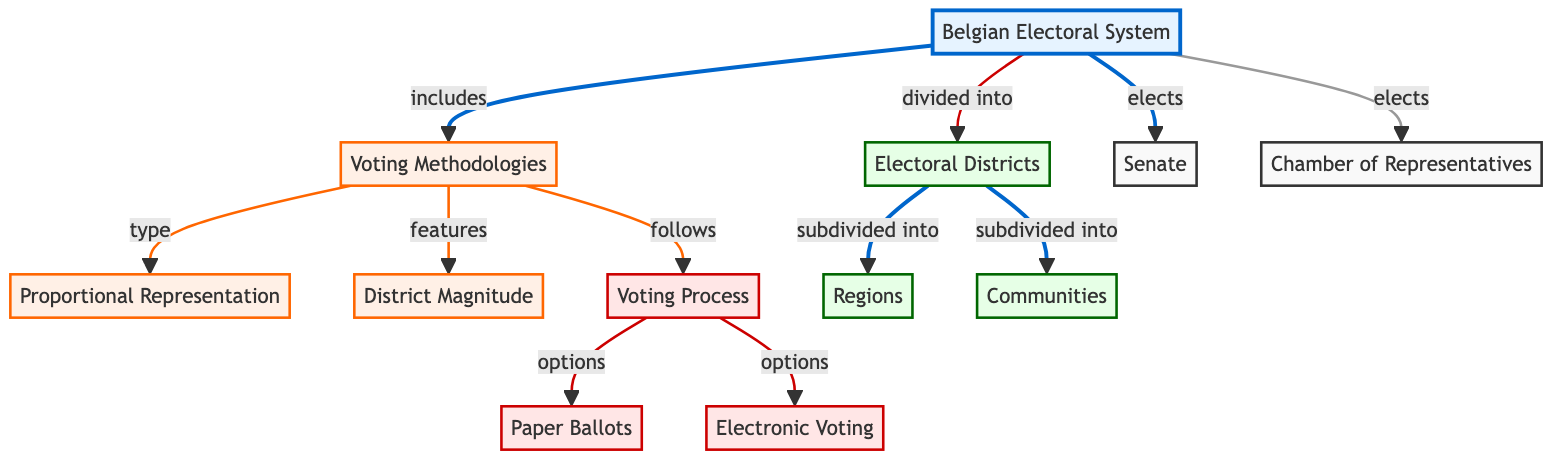What is the main focus of the diagram? The diagram's main focus is the "Belgian Electoral System," which is represented as the central node labeled 1.
Answer: Belgian Electoral System How many voting methodologies are listed in the diagram? In the diagram, there are three voting methodologies identified: Proportional Representation, District Magnitude, and Voting Process. This is counted under node 2.
Answer: three What two types of voting processes are mentioned? The diagram shows two types of voting processes: Paper Ballots and Electronic Voting, both of which are linked to the Voting Process node.
Answer: Paper Ballots, Electronic Voting How many electoral districts are there as per the diagram? The diagram identifies one overarching Electoral District node, which is divided into two subdivisions: Regions and Communities. Therefore, the answer reflects them collectively as subdivisions under it.
Answer: two Which two branches does the Belgian Electoral System elect? The Belgian Electoral System elects two branches, which are clearly labeled under node 1 in the diagram: the Senate and the Chamber of Representatives.
Answer: Senate, Chamber of Representatives What follows under the Voting Process node? Under the Voting Process node in the diagram, two options follow, which are Paper Ballots and Electronic Voting. This reflects the choices available for voters in Belgium.
Answer: Paper Ballots, Electronic Voting How is the Canadian Electoral System divided as per this diagram? According to the diagram, the Belgian Electoral System is divided into Electoral Districts, which are then subdivided into Regions and Communities, indicating a hierarchical structure.
Answer: Electoral Districts, Regions, Communities What type of representation is emphasized in the voting methodologies? The diagram emphasizes "Proportional Representation" as a type of voting methodology, highlighting one of the key features of the Belgian electoral system.
Answer: Proportional Representation What is the main relationship depicted between Electoral Districts and their subdivisions? The main relationship depicted is that Electoral Districts are subdivided into Regions and Communities, indicating how the electoral areas are structured in Belgium.
Answer: subdivided into 